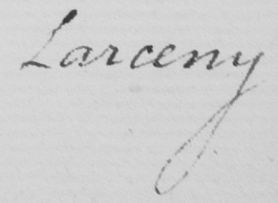Transcribe the text shown in this historical manuscript line. Larceny 